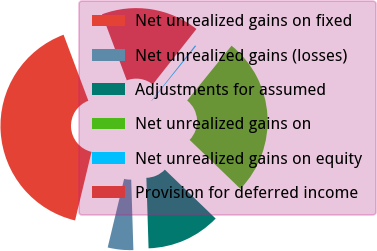Convert chart. <chart><loc_0><loc_0><loc_500><loc_500><pie_chart><fcel>Net unrealized gains on fixed<fcel>Net unrealized gains (losses)<fcel>Adjustments for assumed<fcel>Net unrealized gains on<fcel>Net unrealized gains on equity<fcel>Provision for deferred income<nl><fcel>40.54%<fcel>4.24%<fcel>12.31%<fcel>26.36%<fcel>0.21%<fcel>16.34%<nl></chart> 